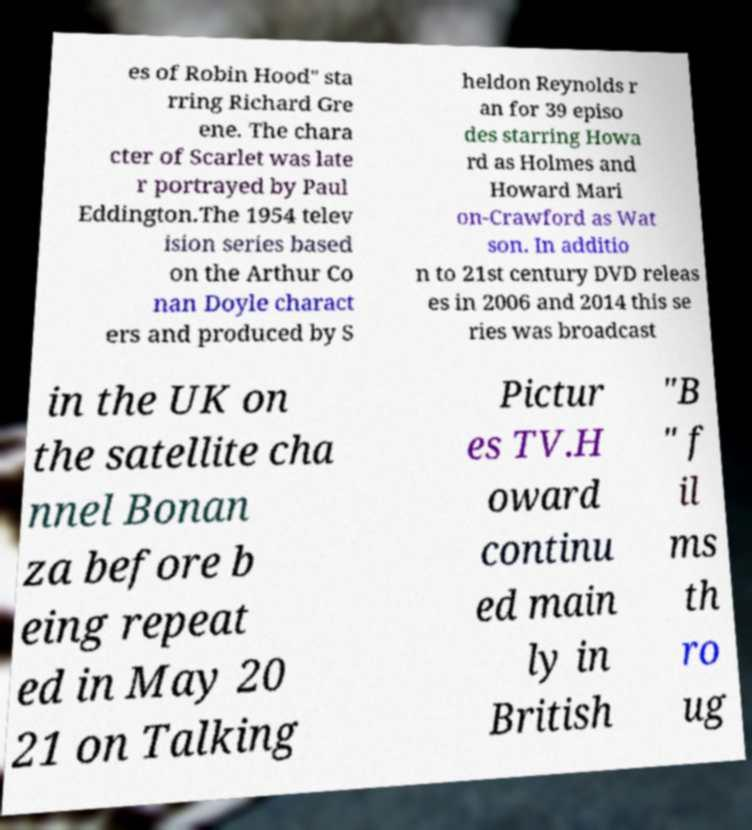Please read and relay the text visible in this image. What does it say? es of Robin Hood" sta rring Richard Gre ene. The chara cter of Scarlet was late r portrayed by Paul Eddington.The 1954 telev ision series based on the Arthur Co nan Doyle charact ers and produced by S heldon Reynolds r an for 39 episo des starring Howa rd as Holmes and Howard Mari on-Crawford as Wat son. In additio n to 21st century DVD releas es in 2006 and 2014 this se ries was broadcast in the UK on the satellite cha nnel Bonan za before b eing repeat ed in May 20 21 on Talking Pictur es TV.H oward continu ed main ly in British "B " f il ms th ro ug 